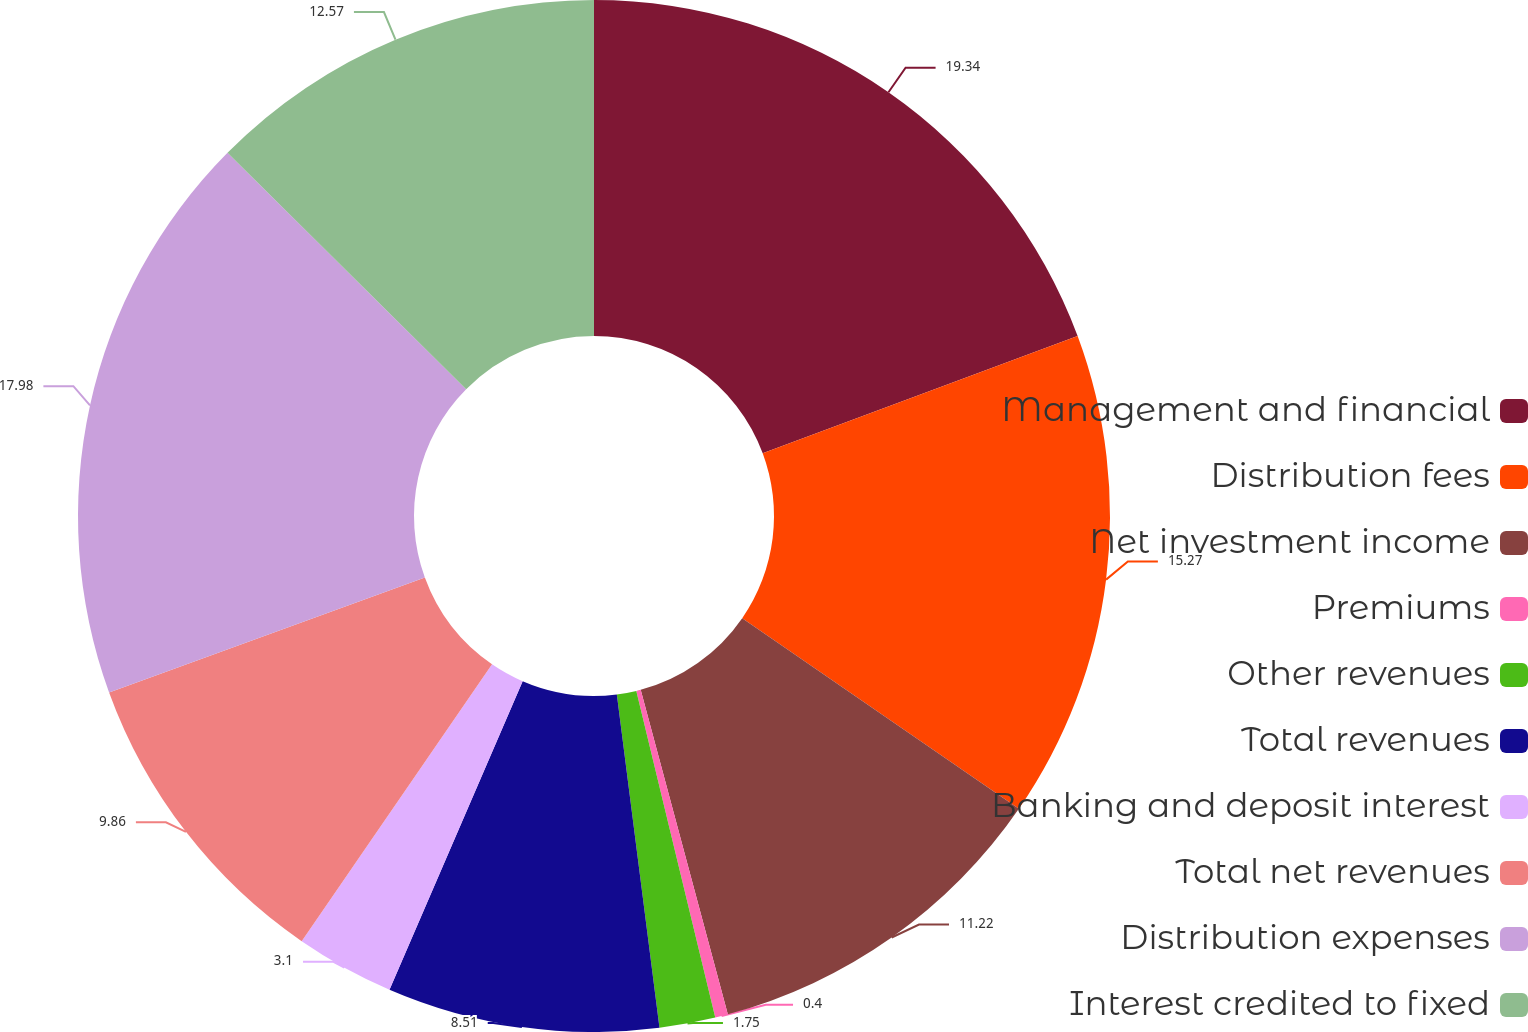Convert chart to OTSL. <chart><loc_0><loc_0><loc_500><loc_500><pie_chart><fcel>Management and financial<fcel>Distribution fees<fcel>Net investment income<fcel>Premiums<fcel>Other revenues<fcel>Total revenues<fcel>Banking and deposit interest<fcel>Total net revenues<fcel>Distribution expenses<fcel>Interest credited to fixed<nl><fcel>19.33%<fcel>15.27%<fcel>11.22%<fcel>0.4%<fcel>1.75%<fcel>8.51%<fcel>3.1%<fcel>9.86%<fcel>17.98%<fcel>12.57%<nl></chart> 